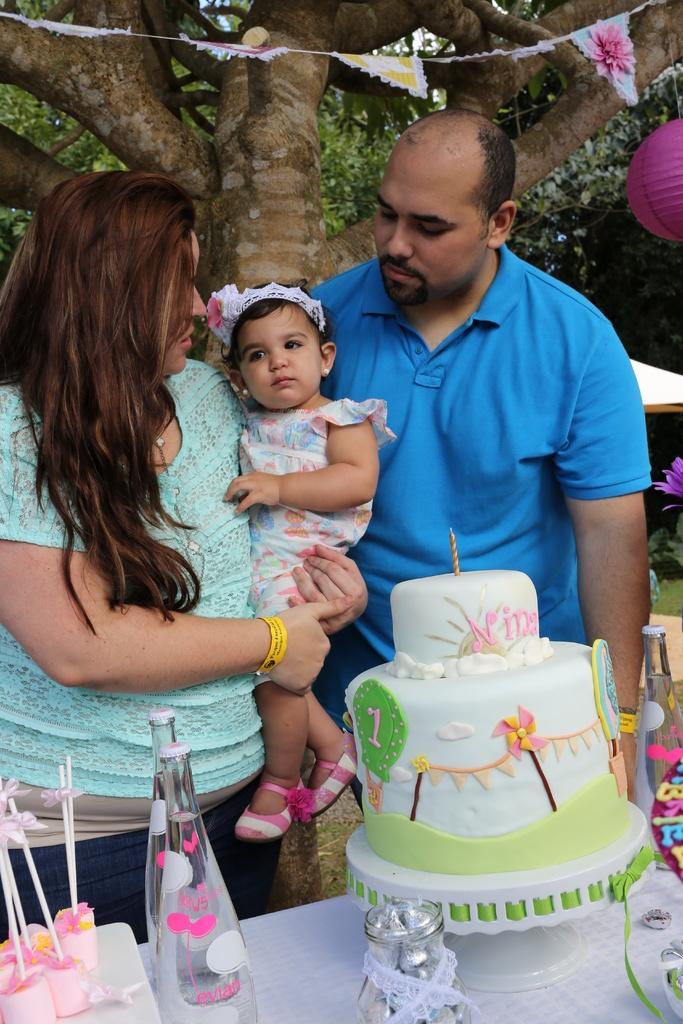In one or two sentences, can you explain what this image depicts? In this picture there is a man who is standing near to the table. On the table I can see the cake, water bottles, chocolates and other objects. On the left there is a woman who is holding a baby girl. In the background I can see the flags and balloons. 